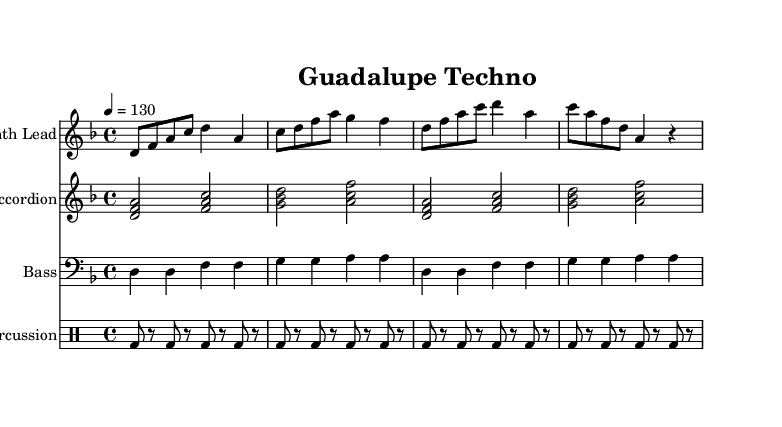What is the key signature of this music? The key signature is D minor, which has one flat (B flat). This is indicated at the beginning of the score.
Answer: D minor What is the time signature of this music? The time signature is 4/4, which means there are four beats in each measure and the quarter note receives one beat. This is shown at the beginning of the piece.
Answer: 4/4 What is the tempo marking indicated in the music? The tempo marking is 4 equals 130, which indicates that each quarter note is to be played at a speed of 130 beats per minute. This is also noted at the beginning of the score.
Answer: 130 How many measures are there in the Synth Lead part? By counting the distinct measures in the Synth Lead staff, there are a total of four measures. Each group of notes is separated by vertical bar lines, which represent the measures.
Answer: 4 What type of instrumentation is used in this piece? This piece features a Synth Lead, Accordion, Bass, and Percussion. The types of staff at the beginning of the score indicate these different instruments.
Answer: Synth Lead, Accordion, Bass, Percussion Is the percussion part strictly in quarter notes? No, the percussion part alternates between eighth notes and rests, showing that it has a rhythm that includes silence as well as sound. The eighth notes are marked by the "bd" and are interspersed with "r" for rest.
Answer: No 